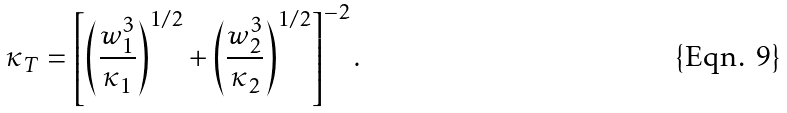Convert formula to latex. <formula><loc_0><loc_0><loc_500><loc_500>\kappa _ { T } = \left [ \left ( \frac { w _ { 1 } ^ { 3 } } { \kappa _ { 1 } } \right ) ^ { 1 / 2 } + \left ( \frac { w _ { 2 } ^ { 3 } } { \kappa _ { 2 } } \right ) ^ { 1 / 2 } \right ] ^ { - 2 } .</formula> 